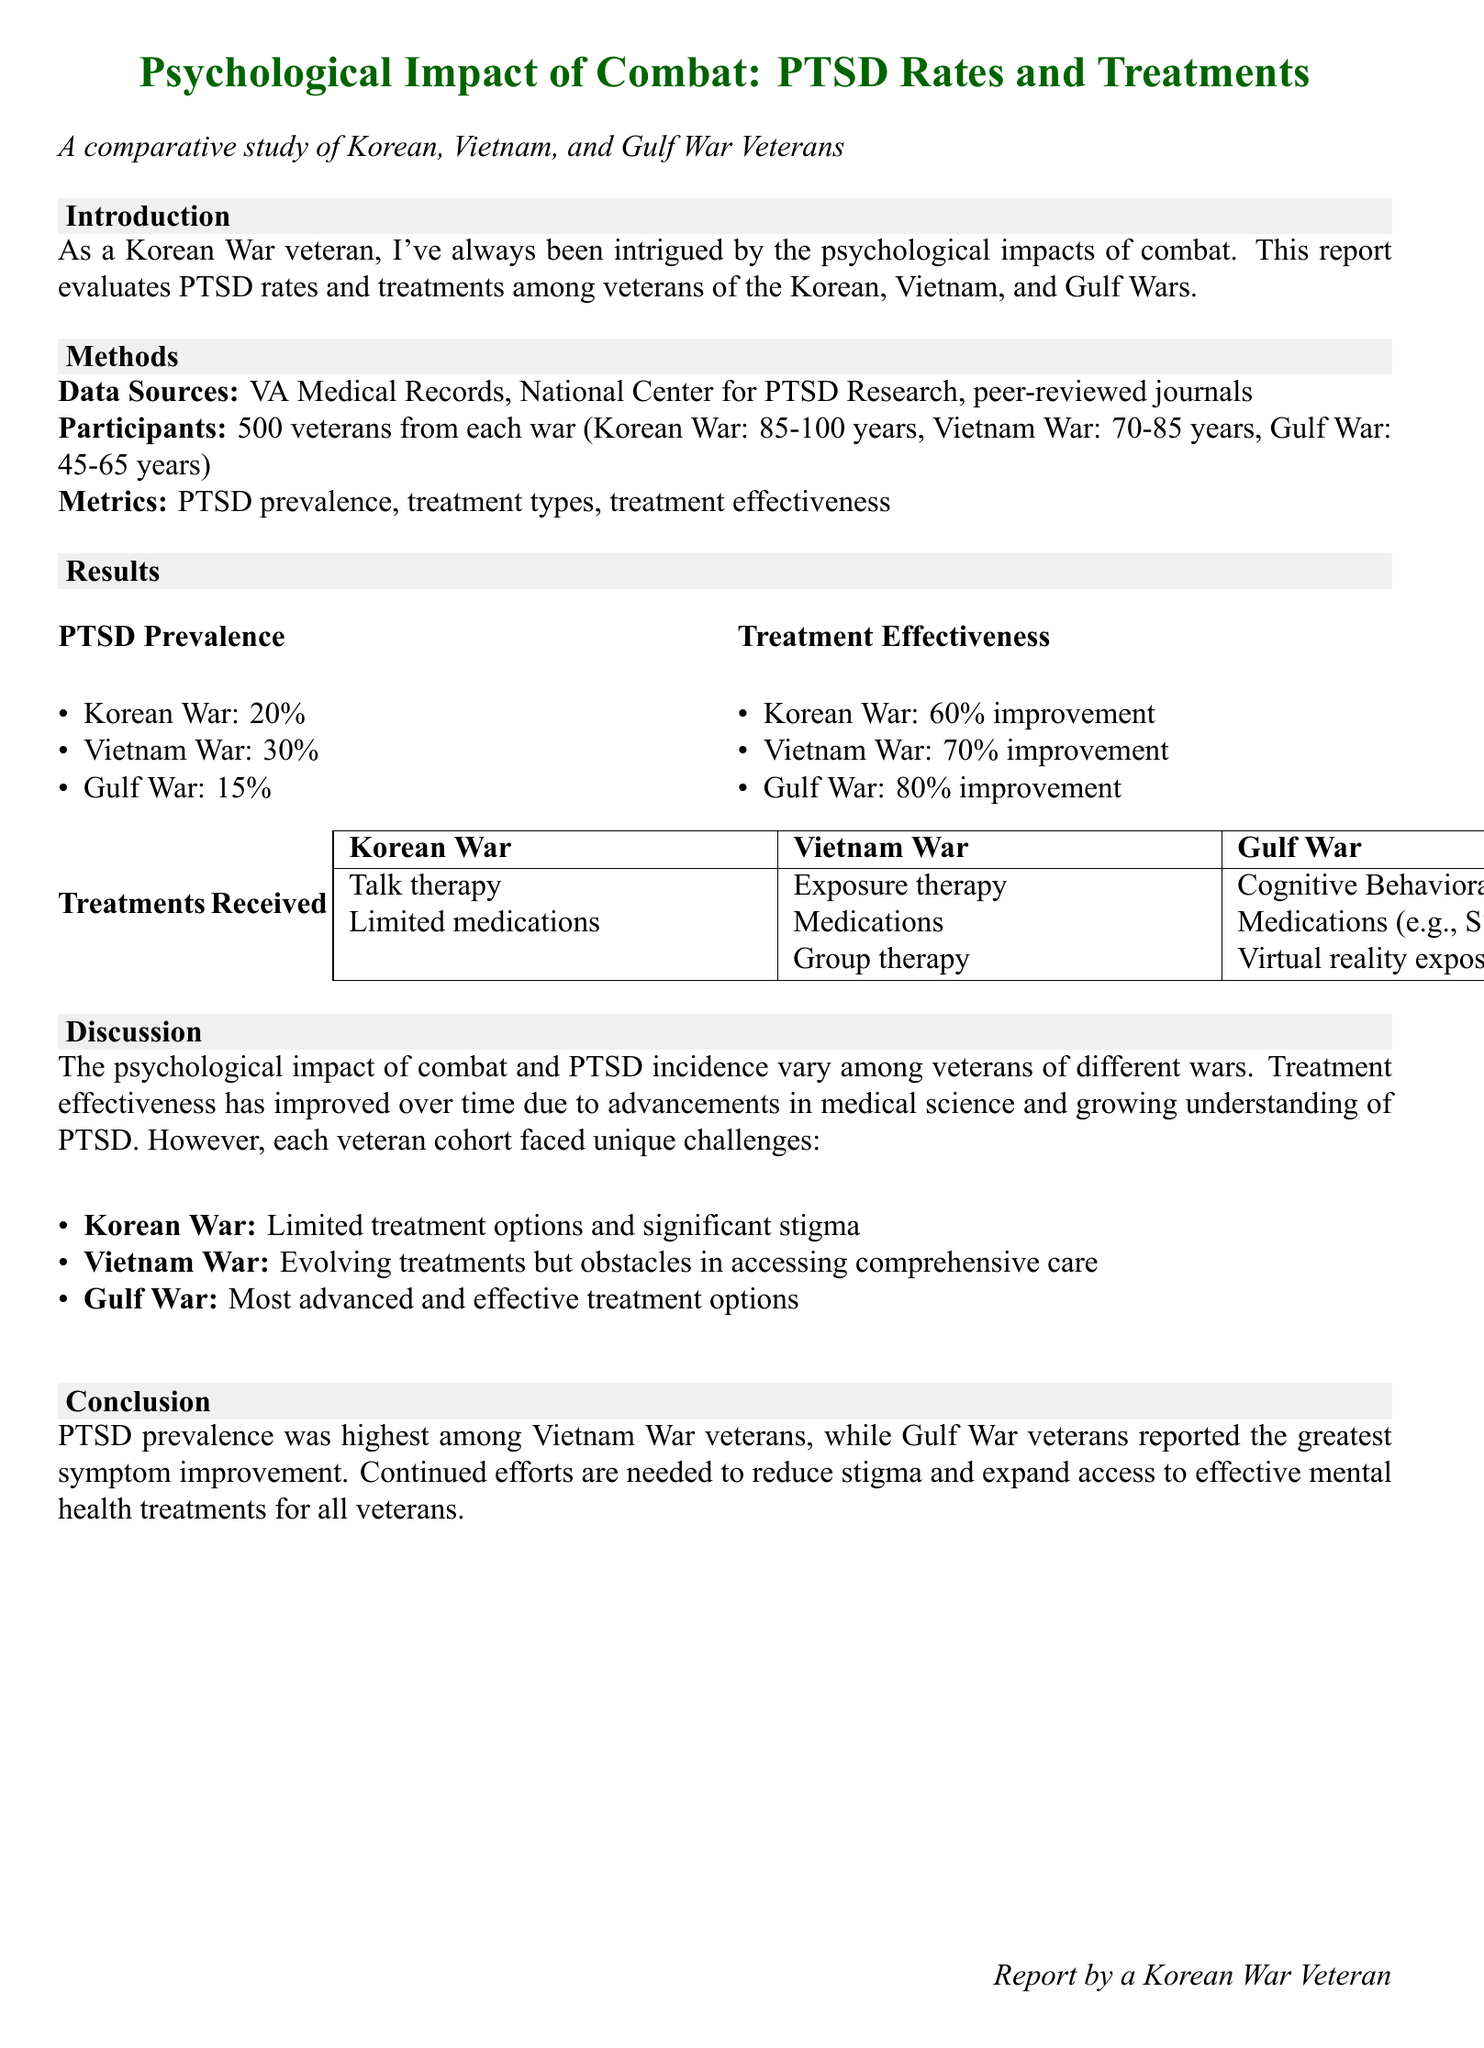What is the PTSD prevalence among Korean War veterans? The document states that 20% of Korean War veterans experience PTSD.
Answer: 20% What treatment had the highest effectiveness for Gulf War veterans? The report mentions that Gulf War veterans had an 80% improvement in treatment effectiveness.
Answer: 80% How many participants were included in the study for each war? The document specifies that there were 500 veterans from each war involved in the study.
Answer: 500 veterans What type of therapy was primarily used for Korean War veterans? The report indicates that talk therapy was the primary treatment used for Korean War veterans.
Answer: Talk therapy Which war had the highest PTSD prevalence rate? According to the document, the Vietnam War had the highest rate of PTSD prevalence at 30%.
Answer: Vietnam War What was a significant barrier faced by Vietnam War veterans in receiving treatment? The report notes that Vietnam War veterans encountered obstacles in accessing comprehensive care.
Answer: Accessing comprehensive care What is the age range of Gulf War veterans in the study? The document states that Gulf War veterans are aged between 45 to 65 years.
Answer: 45-65 years What are two types of treatments received by Gulf War veterans? The report lists medications and virtual reality exposure therapy as treatments received by Gulf War veterans.
Answer: Medications, virtual reality exposure therapy What conclusion is drawn about PTSD prevalence across the conflicts? The conclusion states that PTSD prevalence was highest among Vietnam War veterans.
Answer: Highest among Vietnam War veterans 